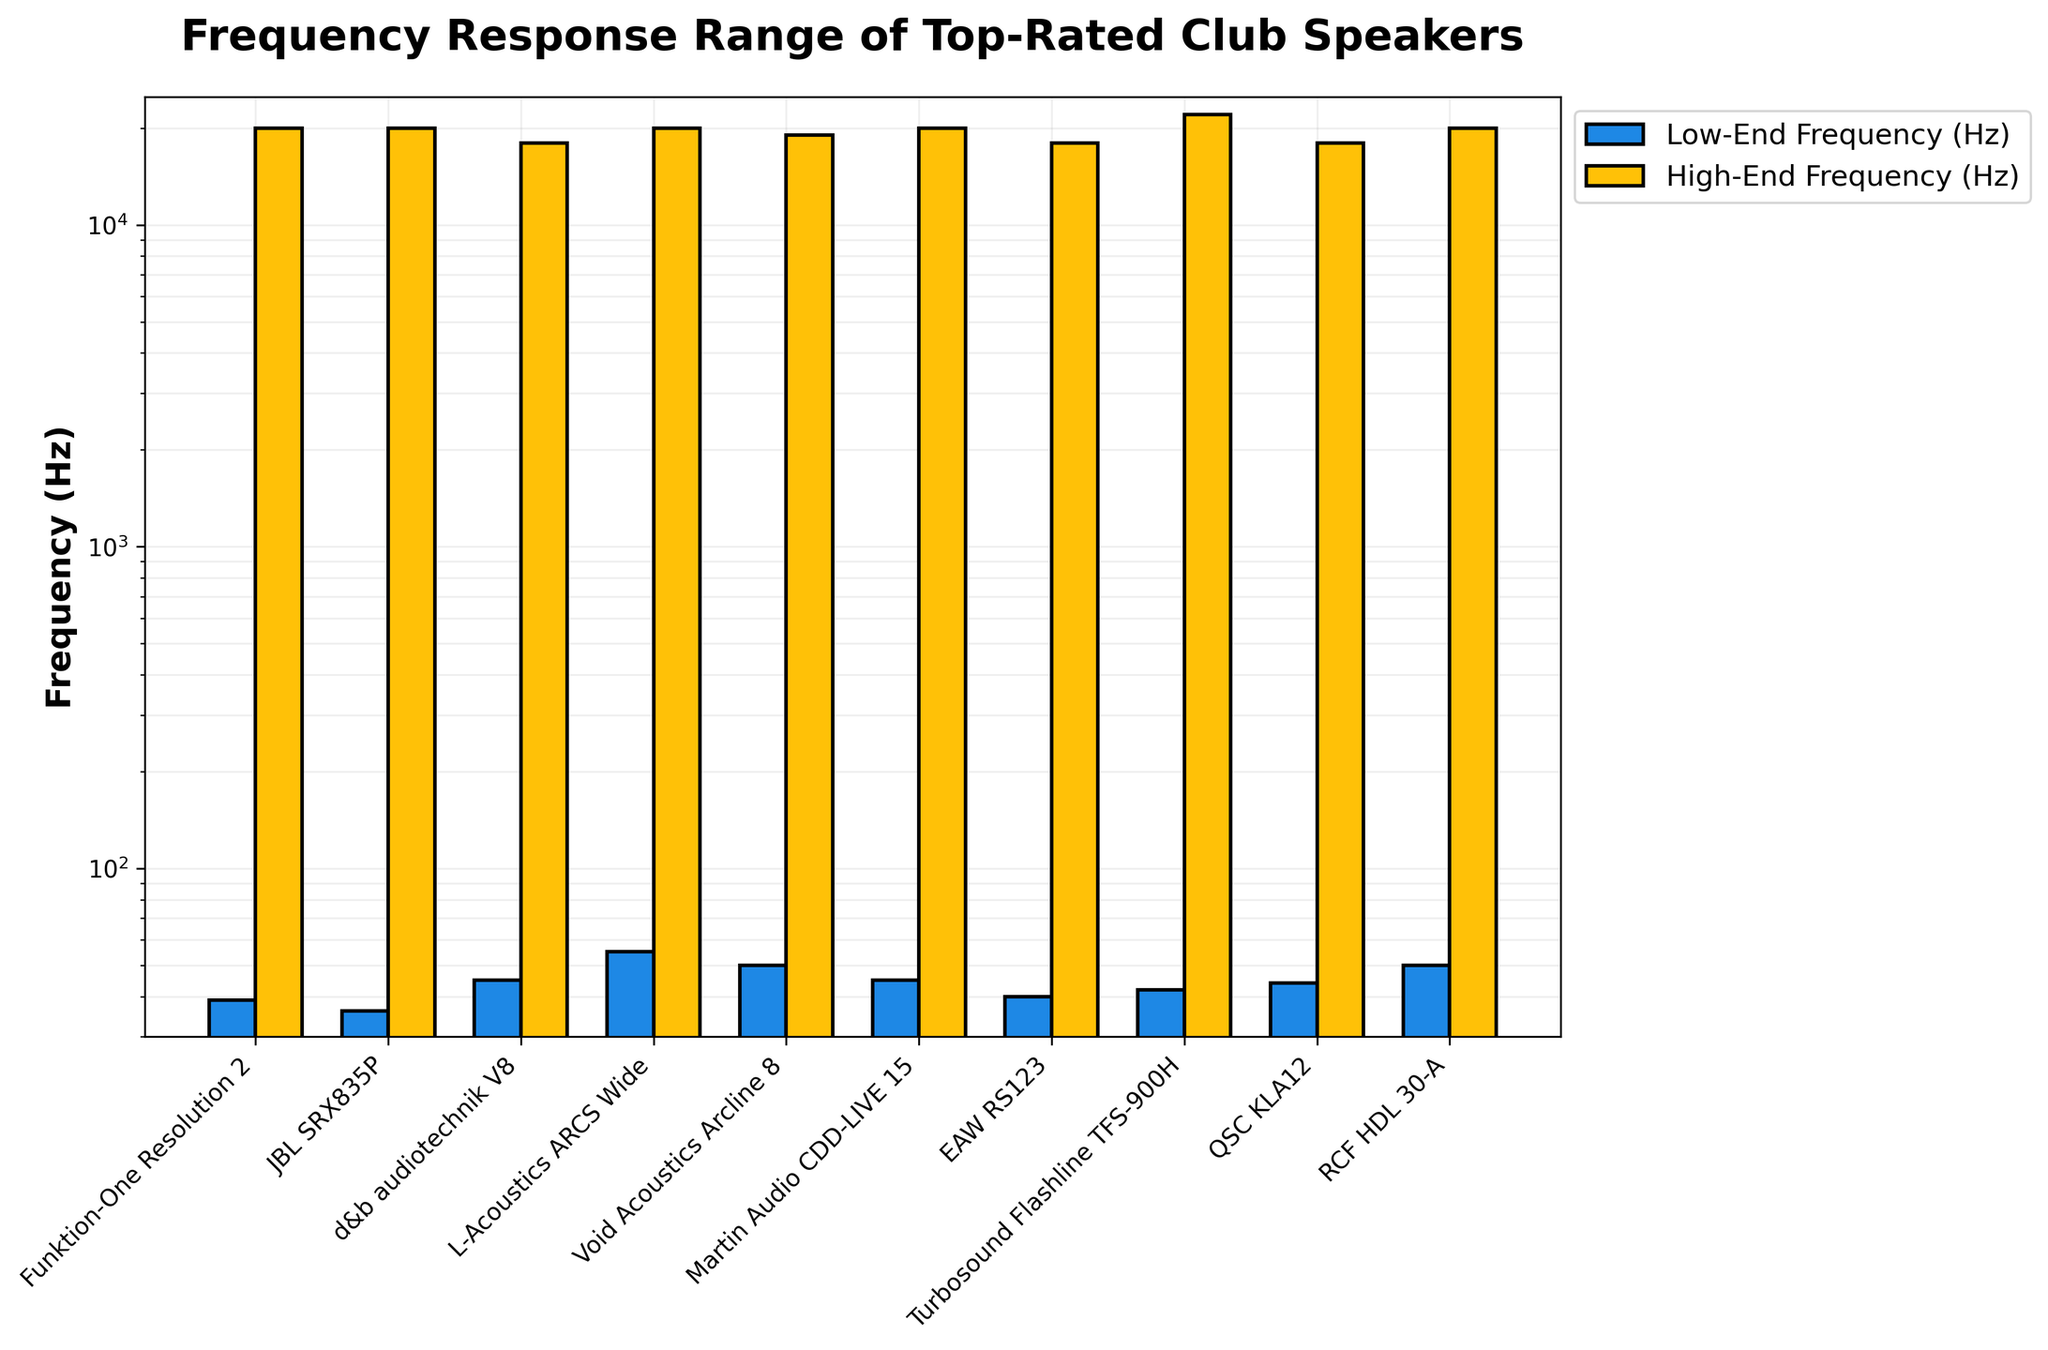What is the highest high-end frequency range among all the speakers? Look for the tallest yellow bar representing the high-end frequency. Turbosound Flashline TFS-900H has the highest high-end frequency at 22 kHz or 22000 Hz.
Answer: 22000 Hz Which speaker has the lowest low-end frequency range? Identify the shortest blue bar representing the low-end frequency. JBL SRX835P has the lowest low-end frequency at 36 Hz.
Answer: JBL SRX835P What is the difference between the high-end and low-end frequencies of the Funktion-One Resolution 2? Subtract the low-end frequency (39 Hz) from the high-end frequency (20000 Hz). The difference is 20000 - 39 = 19961 Hz.
Answer: 19961 Hz How many models have a high-end frequency of exactly 20 kHz? Count the models with yellow bars reaching the 20 kHz line. There are 6 models: Funktion-One Resolution 2, JBL SRX835P, L-Acoustics ARCS Wide, Martin Audio CDD-LIVE 15, and RCF HDL 30-A.
Answer: 6 Which speaker model has the narrowest frequency response range? Calculate the difference between the high-end and low-end frequencies for each model. L-Acoustics ARCS Wide with the range 55-20000 Hz has 20000 - 55 = 19945 Hz. Other ranges: JBL SRX835P (19964 Hz), Funktion-One Resolution 2 (19961 Hz), Turbosound Flashline TFS-900H (21958 Hz), Void Acoustics Arcline 8 (18950 Hz), Martin Audio CDD-LIVE 15 (19955 Hz), EAW RS123 (17960 Hz), d&b audiotechnik V8 (17955 Hz), QSC KLA12 (17956 Hz), RCF HDL 30-A (19950 Hz). The smallest is EAW RS123 with 17960 Hz.
Answer: EAW RS123 Which speaker has the highest low-end frequency, and what's its value? Identify the tallest blue bar representing the low-end frequency. L-Acoustics ARCS Wide and RCF HDL 30-A have the highest low-end frequency of 50 Hz.
Answer: 50 Hz Are there any speakers with a high-end frequency below 20 kHz? If so, which ones? Look for yellow bars below the 20 kHz mark. d&b audiotechnik V8, EAW RS123, and QSC KLA12 have high-end frequencies below 20 kHz.
Answer: d&b audiotechnik V8, EAW RS123, QSC KLA12 What is the average high-end frequency among all speakers? Convert kHz values to Hz, then sum up all high-end frequencies: 20k+20k+18k+20k+19k+20k+18k+22k+18k+20k = 195k Hz. Divide by the number of speakers (10). Average = 195000 / 10 = 19500 Hz.
Answer: 19500 Hz What is the total frequency response range (low-end to high-end) of the JBL SRX835P? Subtract the low-end frequency (36 Hz) from the high-end frequency (20000 Hz). Total range is 20000 - 36 = 19964 Hz.
Answer: 19964 Hz Which speaker has the widest frequency response range? Subtract the low-end from high-end frequency for each speaker. The highest result indicates the widest range. Turbosound Flashline TFS-900H: 21958 Hz. Other speakers have smaller ranges.
Answer: Turbosound Flashline TFS-900H 